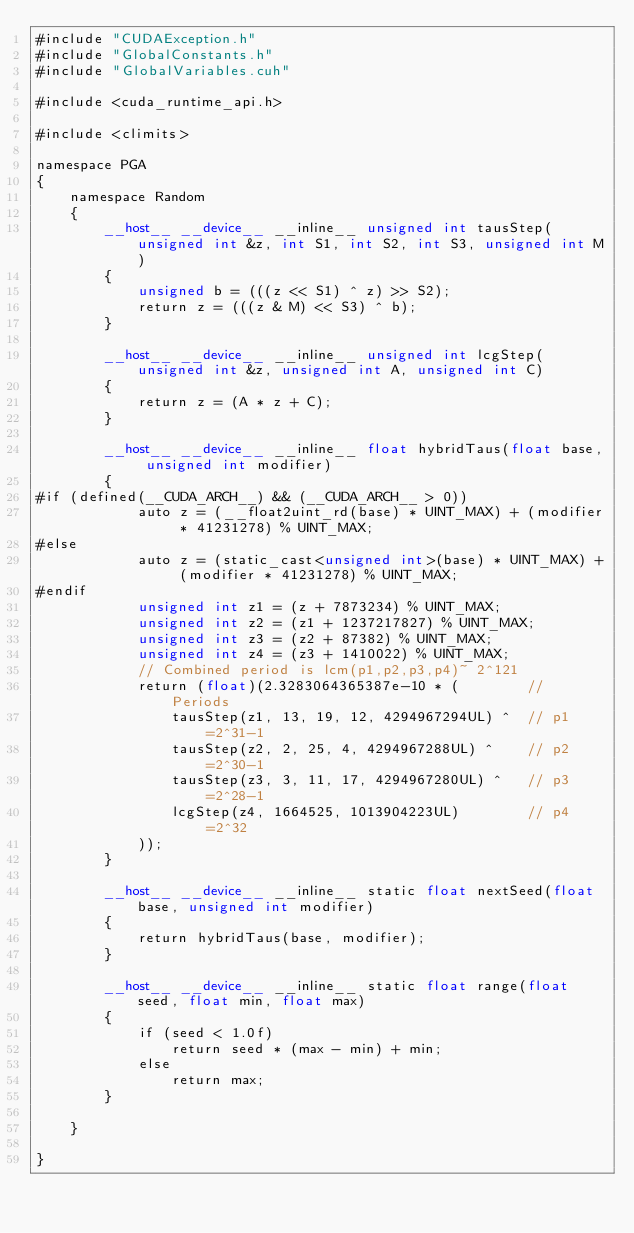Convert code to text. <code><loc_0><loc_0><loc_500><loc_500><_Cuda_>#include "CUDAException.h"
#include "GlobalConstants.h"
#include "GlobalVariables.cuh"

#include <cuda_runtime_api.h>

#include <climits>

namespace PGA
{
	namespace Random
	{
		__host__ __device__ __inline__ unsigned int tausStep(unsigned int &z, int S1, int S2, int S3, unsigned int M)
		{
			unsigned b = (((z << S1) ^ z) >> S2);
			return z = (((z & M) << S3) ^ b);
		}

		__host__ __device__ __inline__ unsigned int lcgStep(unsigned int &z, unsigned int A, unsigned int C)
		{
			return z = (A * z + C);
		}

		__host__ __device__ __inline__ float hybridTaus(float base, unsigned int modifier)
		{
#if (defined(__CUDA_ARCH__) && (__CUDA_ARCH__ > 0))
			auto z = (__float2uint_rd(base) * UINT_MAX) + (modifier * 41231278) % UINT_MAX;
#else
			auto z = (static_cast<unsigned int>(base) * UINT_MAX) + (modifier * 41231278) % UINT_MAX;
#endif
			unsigned int z1 = (z + 7873234) % UINT_MAX;
			unsigned int z2 = (z1 + 1237217827) % UINT_MAX;
			unsigned int z3 = (z2 + 87382) % UINT_MAX;
			unsigned int z4 = (z3 + 1410022) % UINT_MAX;
			// Combined period is lcm(p1,p2,p3,p4)~ 2^121  
			return (float)(2.3283064365387e-10 * (        // Periods  
				tausStep(z1, 13, 19, 12, 4294967294UL) ^  // p1=2^31-1  
				tausStep(z2, 2, 25, 4, 4294967288UL) ^    // p2=2^30-1  
				tausStep(z3, 3, 11, 17, 4294967280UL) ^   // p3=2^28-1  
				lcgStep(z4, 1664525, 1013904223UL)        // p4=2^32  
			));
		}

		__host__ __device__ __inline__ static float nextSeed(float base, unsigned int modifier)
		{
			return hybridTaus(base, modifier);
		}

		__host__ __device__ __inline__ static float range(float seed, float min, float max)
		{
			if (seed < 1.0f)
				return seed * (max - min) + min;
			else
				return max;
		}

	}

}
</code> 